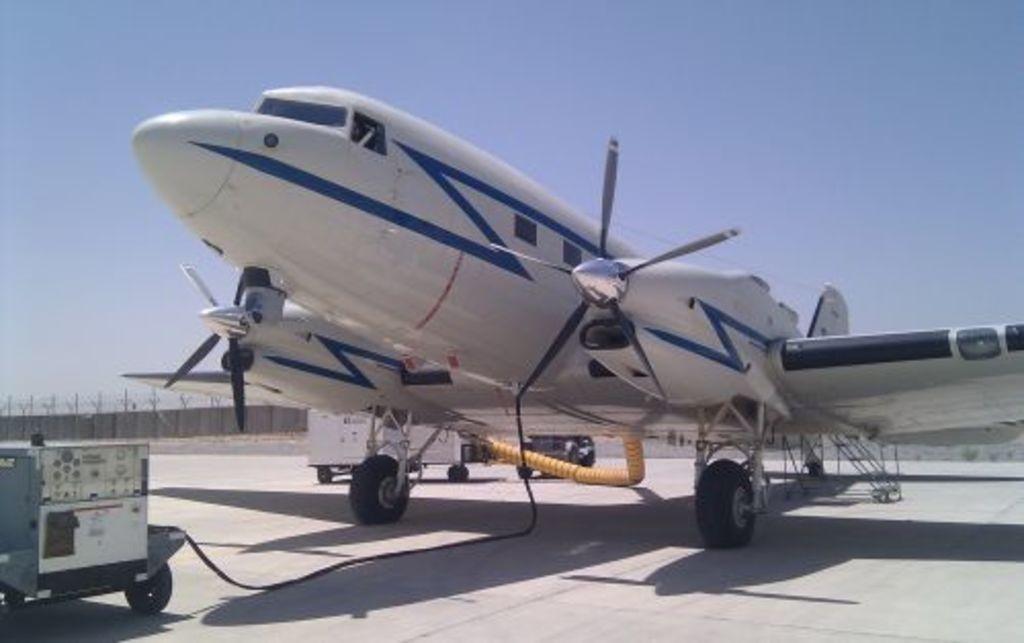Could you give a brief overview of what you see in this image? In this image, we can see an airplane and vehicles are on the path. In the background, we can see wall, poles, fence and sky. 